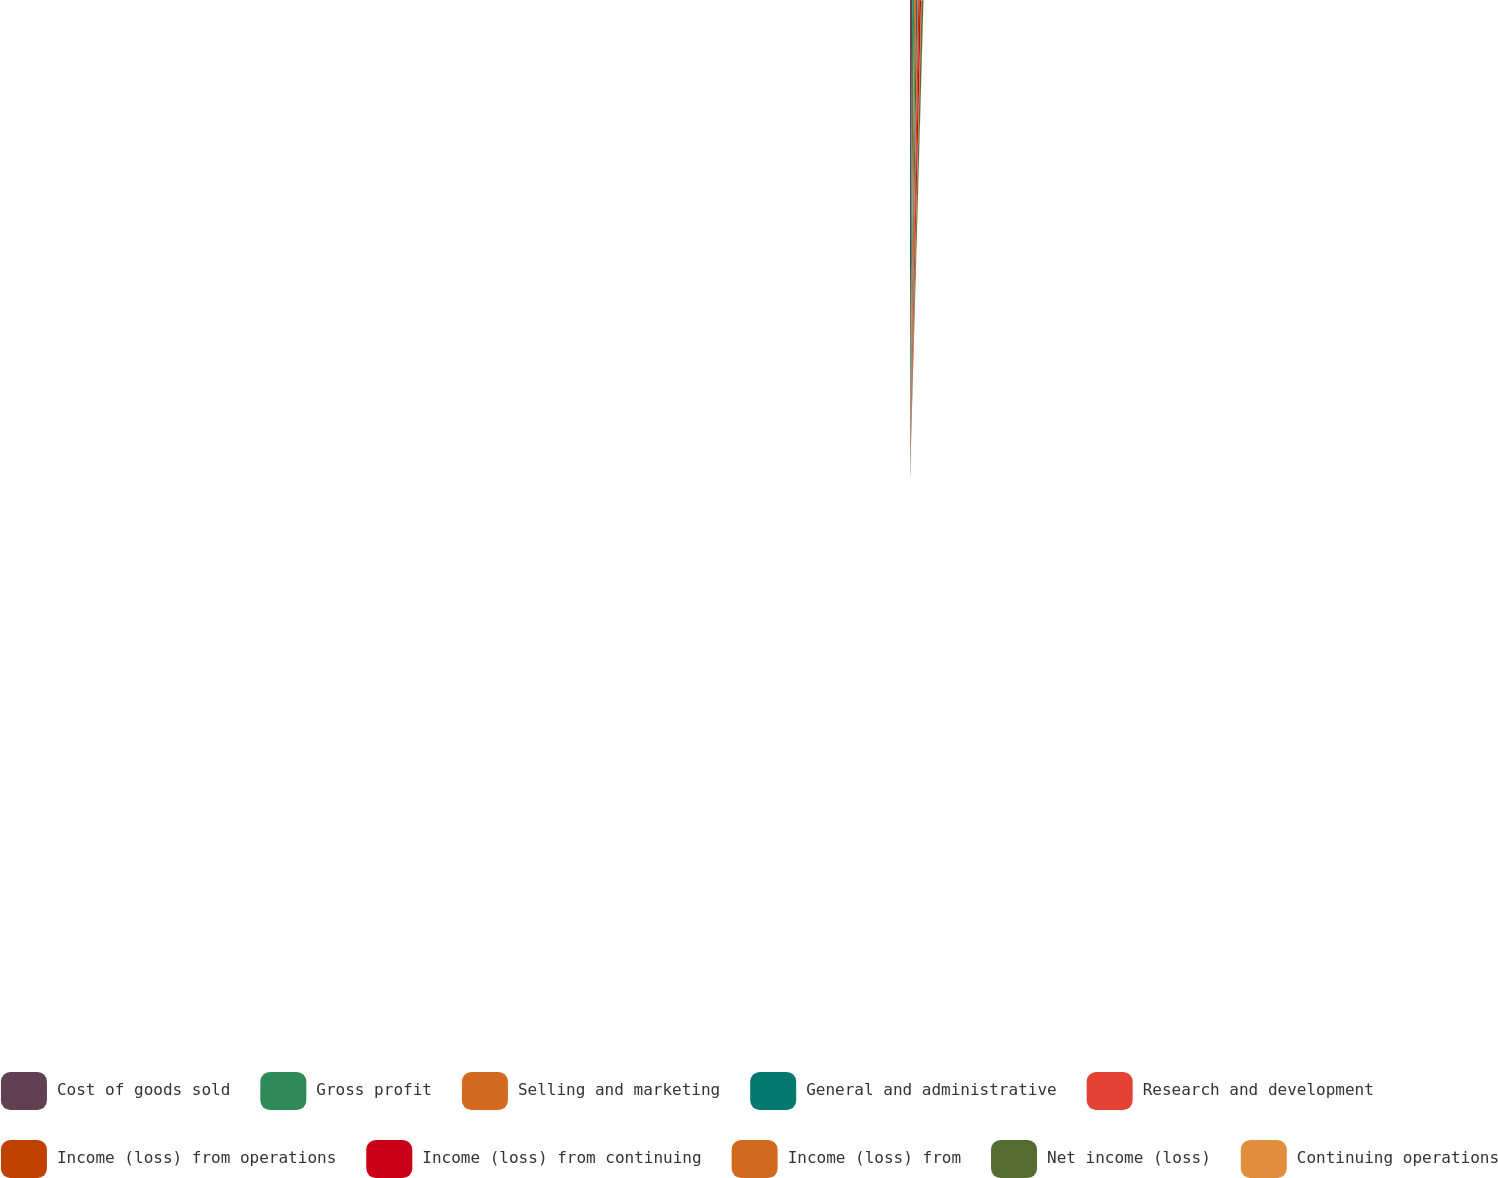<chart> <loc_0><loc_0><loc_500><loc_500><pie_chart><fcel>Cost of goods sold<fcel>Gross profit<fcel>Selling and marketing<fcel>General and administrative<fcel>Research and development<fcel>Income (loss) from operations<fcel>Income (loss) from continuing<fcel>Income (loss) from<fcel>Net income (loss)<fcel>Continuing operations<nl><fcel>16.09%<fcel>14.94%<fcel>13.79%<fcel>10.34%<fcel>5.75%<fcel>9.2%<fcel>11.49%<fcel>4.6%<fcel>12.64%<fcel>1.15%<nl></chart> 